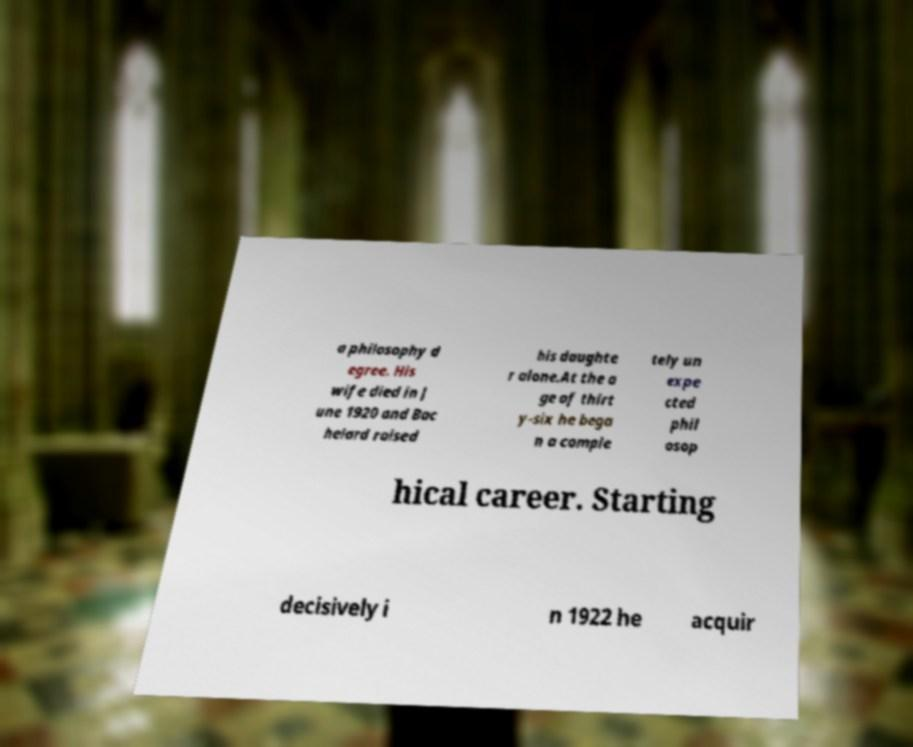Could you extract and type out the text from this image? a philosophy d egree. His wife died in J une 1920 and Bac helard raised his daughte r alone.At the a ge of thirt y-six he bega n a comple tely un expe cted phil osop hical career. Starting decisively i n 1922 he acquir 